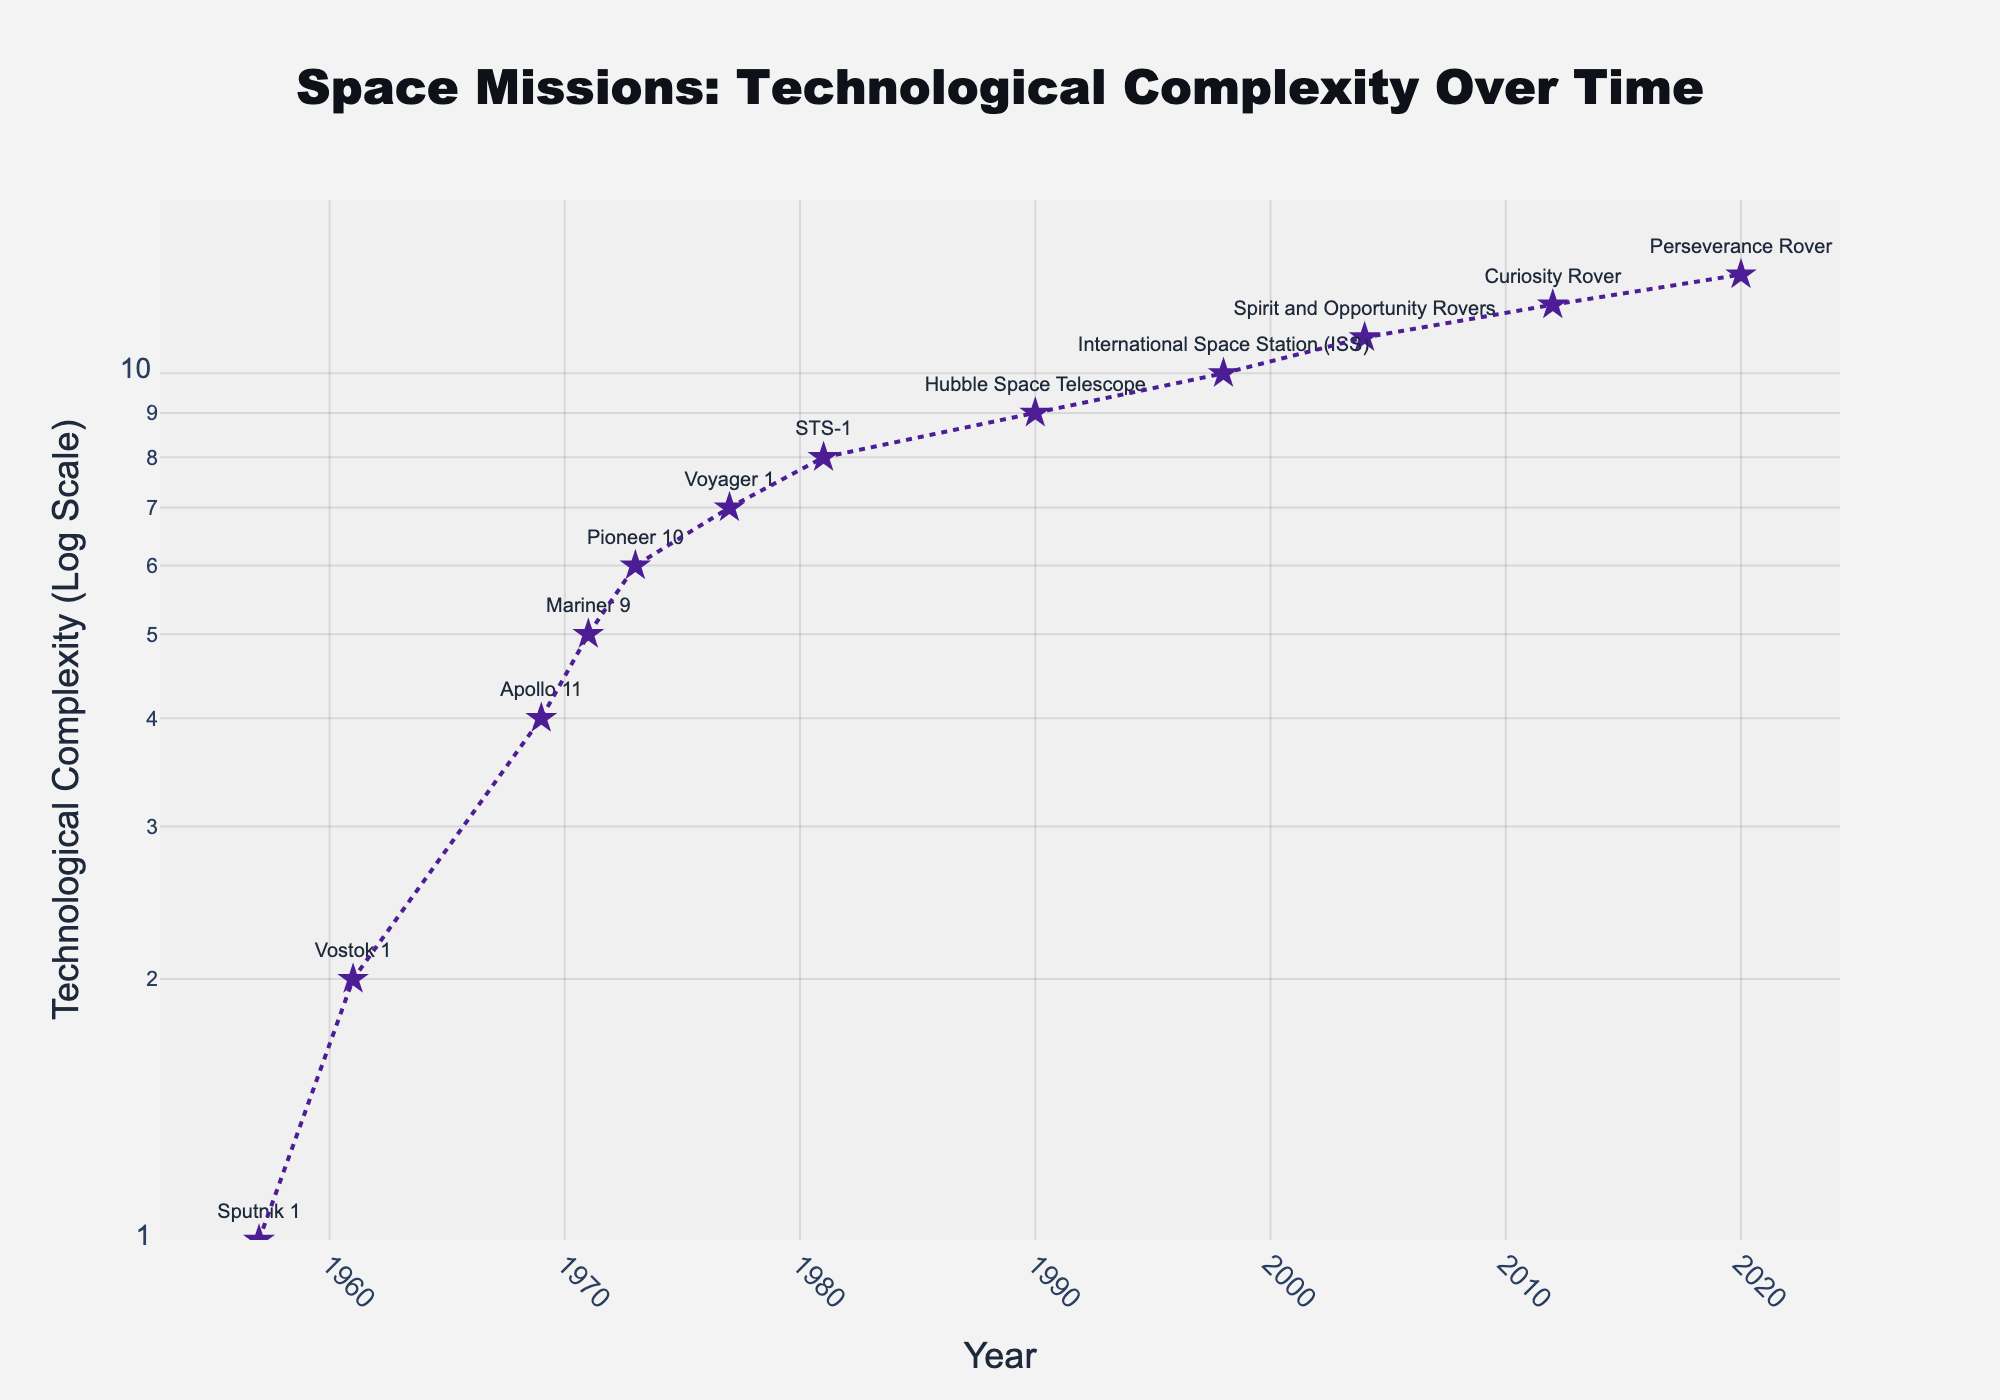What is the title of the figure? The title is displayed prominently at the top of the figure and provides a clear indication of what the plot represents.
Answer: Space Missions: Technological Complexity Over Time Which mission had the lowest technological complexity? By looking at the bottom of the y-axis (log scale) and reading the corresponding mission name, we can identify the mission with the lowest complexity.
Answer: Sputnik 1 What is the technological complexity of the Curiosity Rover mission in 2012? Locate the data point corresponding to the year 2012 and check the y-axis value tied to it.
Answer: 12 How many missions are plotted on the figure? Count all the unique data points or mission names provided in the plot.
Answer: 12 Which mission came right after Apollo 11 in terms of technological complexity? Find Apollo 11 on the plot, then look for the next mission along the y-axis to determine the sequential mission based on technological complexity.
Answer: Mariner 9 What is the interval frequency of the x-axis ticks? Examine the spacing between the year labels on the x-axis to determine the regular interval.
Answer: 10 years How much more complex was the Hubble Space Telescope compared to the Apollo 11 mission? Identify the y-axis values for both missions and subtract the technological complexity of Apollo 11 from the Hubble Space Telescope.
Answer: 5 Did technological complexity increase steadily over the years? Observe the connecting lines between data points on the plot to assess whether the complexity shows a steady increase, sudden jumps, or plateaus.
Answer: Yes, it increased steadily Which mission had the highest technological complexity? Locate the topmost data point on the y-axis (log scale) and read the corresponding mission name.
Answer: Perseverance Rover What is the range of years covered by the missions in the figure? Determine the earliest and the latest year from the x-axis to find the range.
Answer: 1957 to 2020 